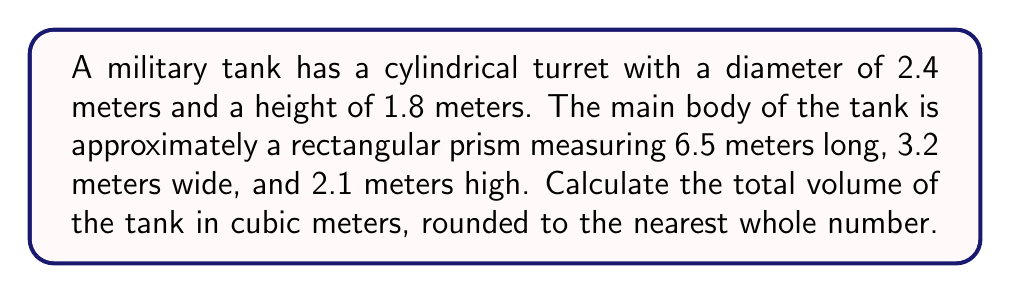Help me with this question. Let's break this down step-by-step:

1. Calculate the volume of the cylindrical turret:
   Using the formula $V = \pi r^2 h$
   Radius $r = 2.4 \text{ m} \div 2 = 1.2 \text{ m}$
   Height $h = 1.8 \text{ m}$
   
   $$V_{\text{turret}} = \pi (1.2 \text{ m})^2 (1.8 \text{ m}) = 8.14 \text{ m}^3$$

2. Calculate the volume of the rectangular prism main body:
   Using the formula $V = l \times w \times h$
   Length $l = 6.5 \text{ m}$
   Width $w = 3.2 \text{ m}$
   Height $h = 2.1 \text{ m}$
   
   $$V_{\text{body}} = 6.5 \text{ m} \times 3.2 \text{ m} \times 2.1 \text{ m} = 43.68 \text{ m}^3$$

3. Sum up the volumes:
   $$V_{\text{total}} = V_{\text{turret}} + V_{\text{body}} = 8.14 \text{ m}^3 + 43.68 \text{ m}^3 = 51.82 \text{ m}^3$$

4. Round to the nearest whole number:
   51.82 rounds to 52
Answer: 52 m³ 